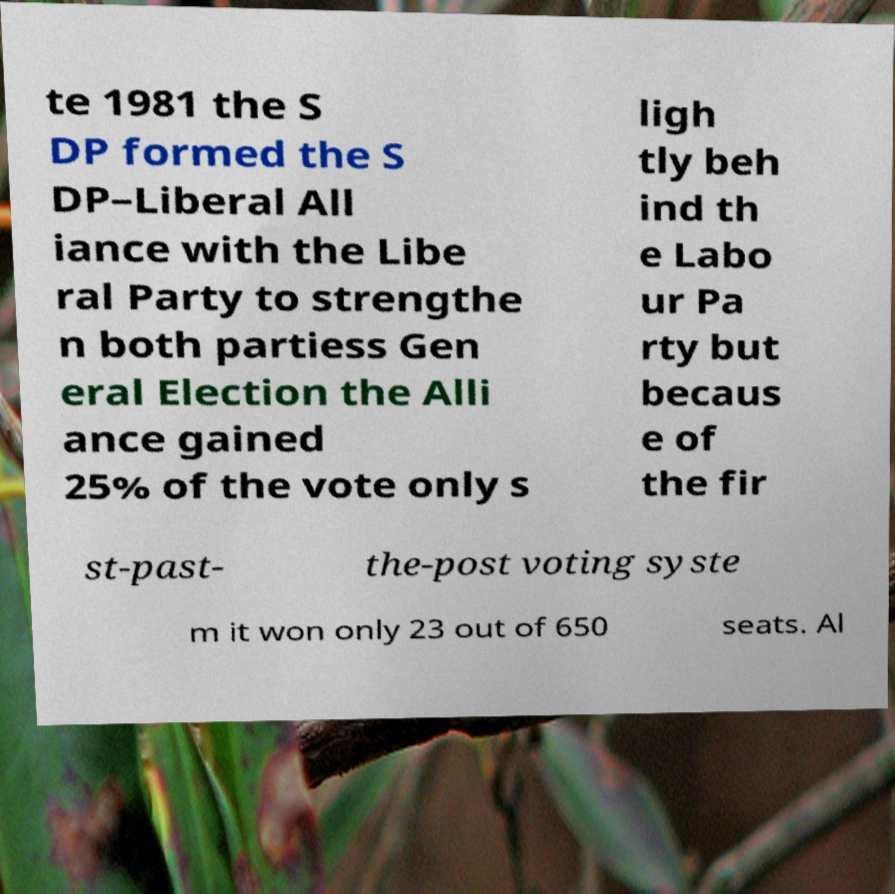Please read and relay the text visible in this image. What does it say? te 1981 the S DP formed the S DP–Liberal All iance with the Libe ral Party to strengthe n both partiess Gen eral Election the Alli ance gained 25% of the vote only s ligh tly beh ind th e Labo ur Pa rty but becaus e of the fir st-past- the-post voting syste m it won only 23 out of 650 seats. Al 